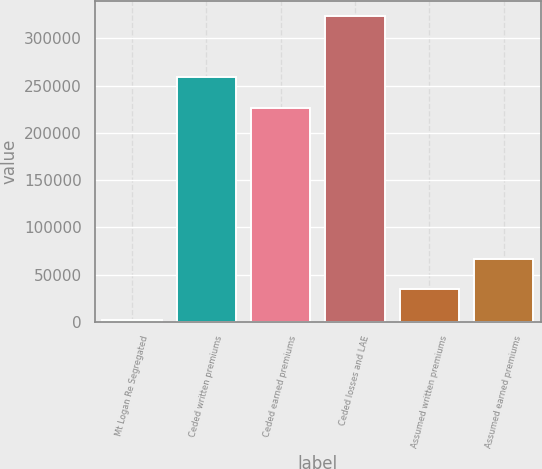Convert chart to OTSL. <chart><loc_0><loc_0><loc_500><loc_500><bar_chart><fcel>Mt Logan Re Segregated<fcel>Ceded written premiums<fcel>Ceded earned premiums<fcel>Ceded losses and LAE<fcel>Assumed written premiums<fcel>Assumed earned premiums<nl><fcel>2017<fcel>258670<fcel>226505<fcel>323664<fcel>34181.7<fcel>66346.4<nl></chart> 